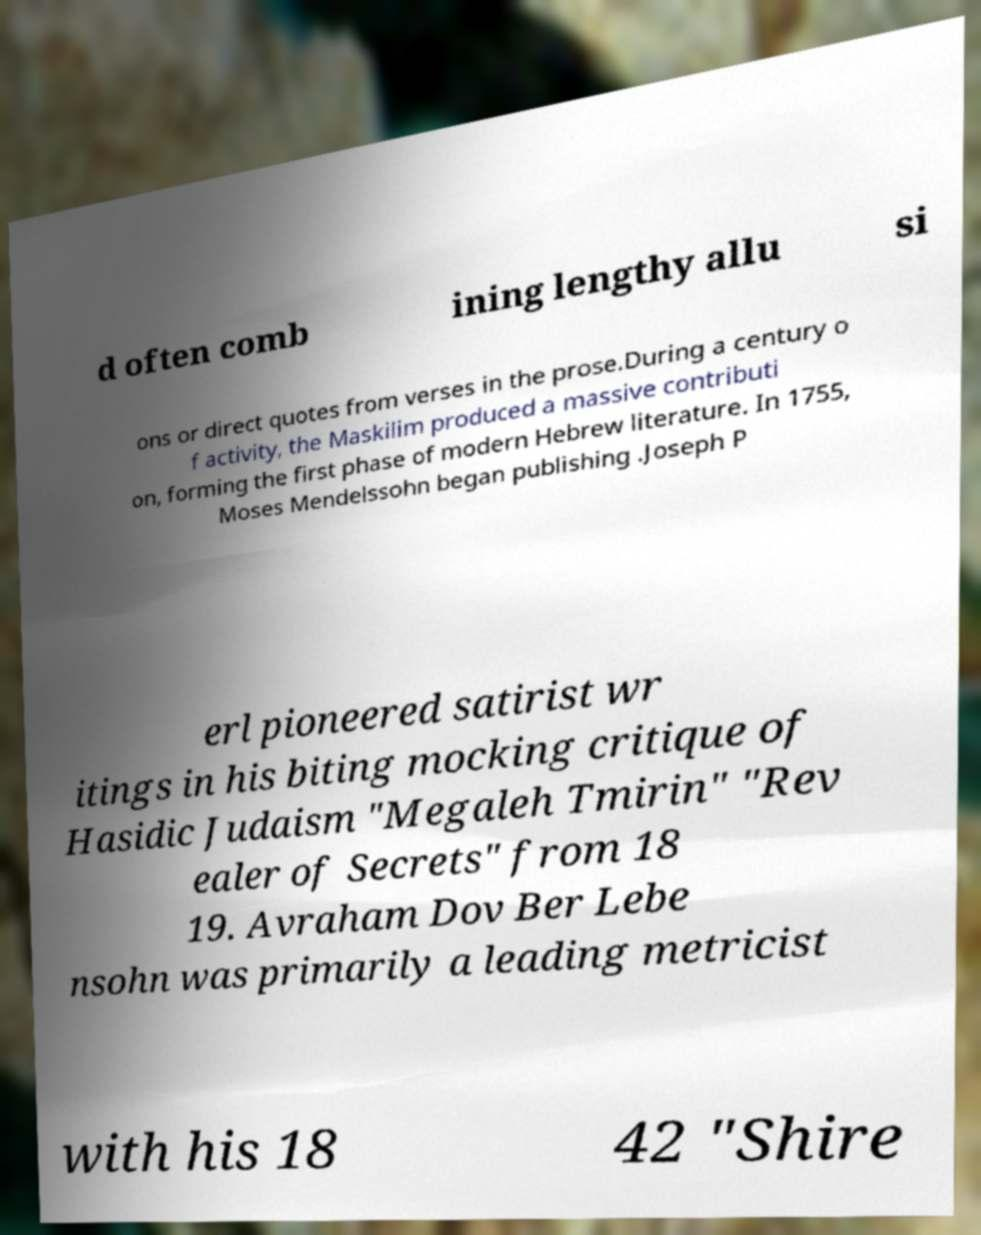What messages or text are displayed in this image? I need them in a readable, typed format. d often comb ining lengthy allu si ons or direct quotes from verses in the prose.During a century o f activity, the Maskilim produced a massive contributi on, forming the first phase of modern Hebrew literature. In 1755, Moses Mendelssohn began publishing .Joseph P erl pioneered satirist wr itings in his biting mocking critique of Hasidic Judaism "Megaleh Tmirin" "Rev ealer of Secrets" from 18 19. Avraham Dov Ber Lebe nsohn was primarily a leading metricist with his 18 42 "Shire 